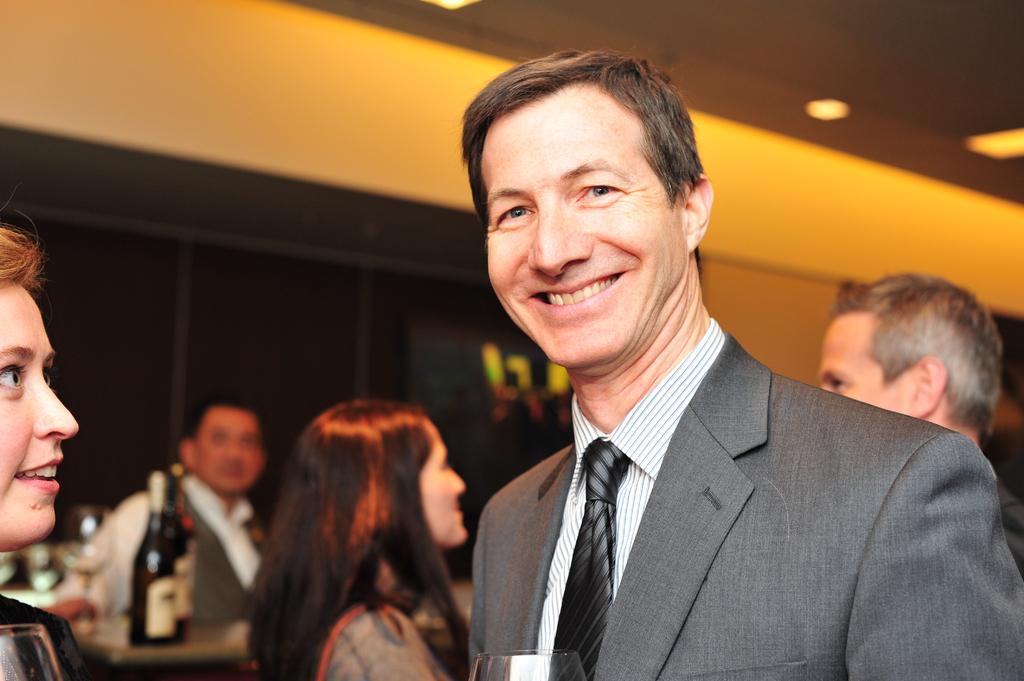What is the main subject in the foreground of the image? There is a person standing in the foreground of the image. What is the person wearing in the image? The person is wearing a blazer. Can you describe the background of the image? There are other persons standing in the background of the image, and there is a wall behind them. What color is the pen being used by the person in the image? There is no pen visible in the image, so it is not possible to determine its color. 